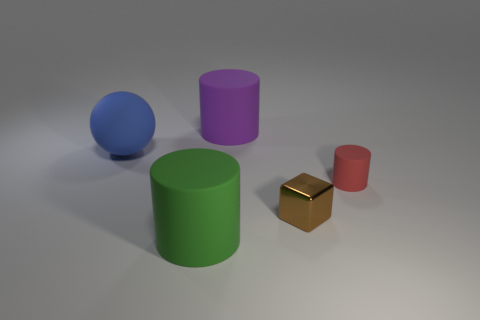What number of objects are matte cylinders that are to the left of the tiny red rubber cylinder or tiny objects that are in front of the red cylinder?
Give a very brief answer. 3. How many things are large blue things or large rubber cylinders that are in front of the red matte object?
Your answer should be very brief. 2. How big is the thing that is on the left side of the cylinder that is in front of the cylinder to the right of the metallic cube?
Make the answer very short. Large. What is the material of the purple object that is the same size as the blue matte sphere?
Ensure brevity in your answer.  Rubber. Is there another green matte thing that has the same size as the green thing?
Provide a short and direct response. No. There is a object that is behind the blue object; does it have the same size as the green cylinder?
Ensure brevity in your answer.  Yes. What is the shape of the big thing that is in front of the big purple matte cylinder and behind the green matte cylinder?
Provide a succinct answer. Sphere. Is the number of red matte things that are in front of the small cube greater than the number of big yellow matte cubes?
Your answer should be very brief. No. There is a red thing that is made of the same material as the big green cylinder; what is its size?
Your answer should be very brief. Small. What number of shiny blocks are the same color as the metal object?
Provide a short and direct response. 0. 